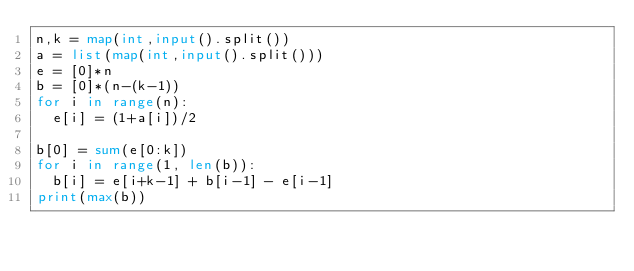Convert code to text. <code><loc_0><loc_0><loc_500><loc_500><_Python_>n,k = map(int,input().split())
a = list(map(int,input().split()))
e = [0]*n
b = [0]*(n-(k-1))
for i in range(n):
  e[i] = (1+a[i])/2

b[0] = sum(e[0:k])
for i in range(1, len(b)):
  b[i] = e[i+k-1] + b[i-1] - e[i-1]
print(max(b))</code> 